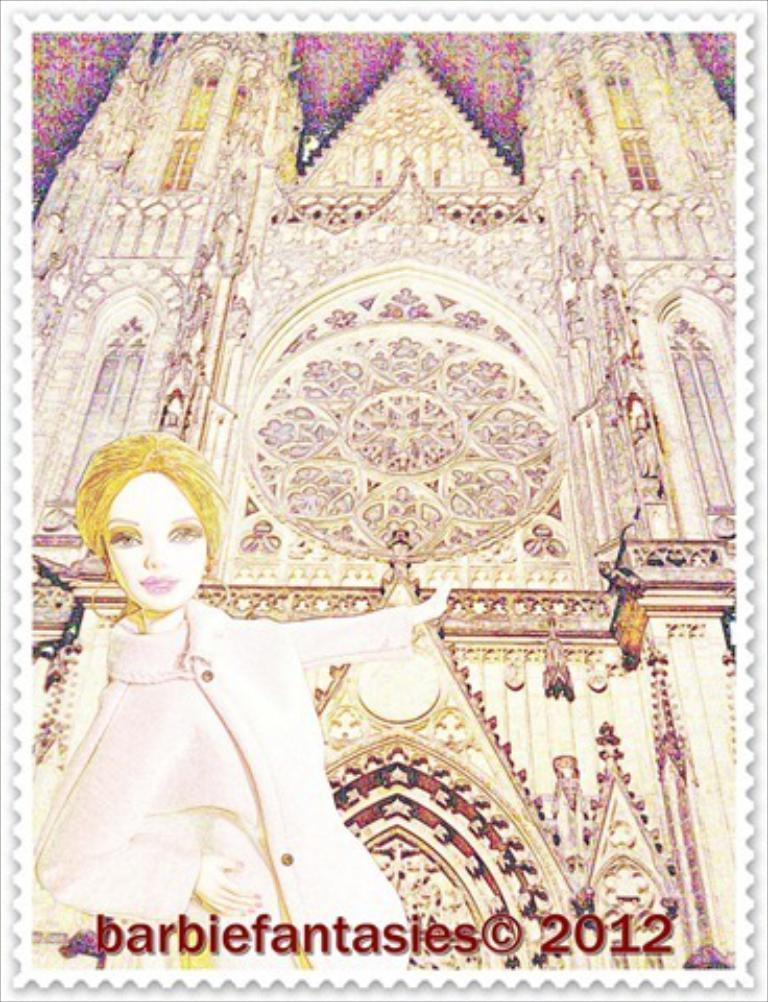What is the main subject of the image? The main subject of the image is a postage stamp. What can be seen in the picture on the postage stamp? The postage stamp has a picture of a woman and a building. Are there any words or letters on the postage stamp? Yes, there is text on the postage stamp. How does the postage stamp expand in the image? The postage stamp does not expand in the image; it is a static image of a postage stamp. 